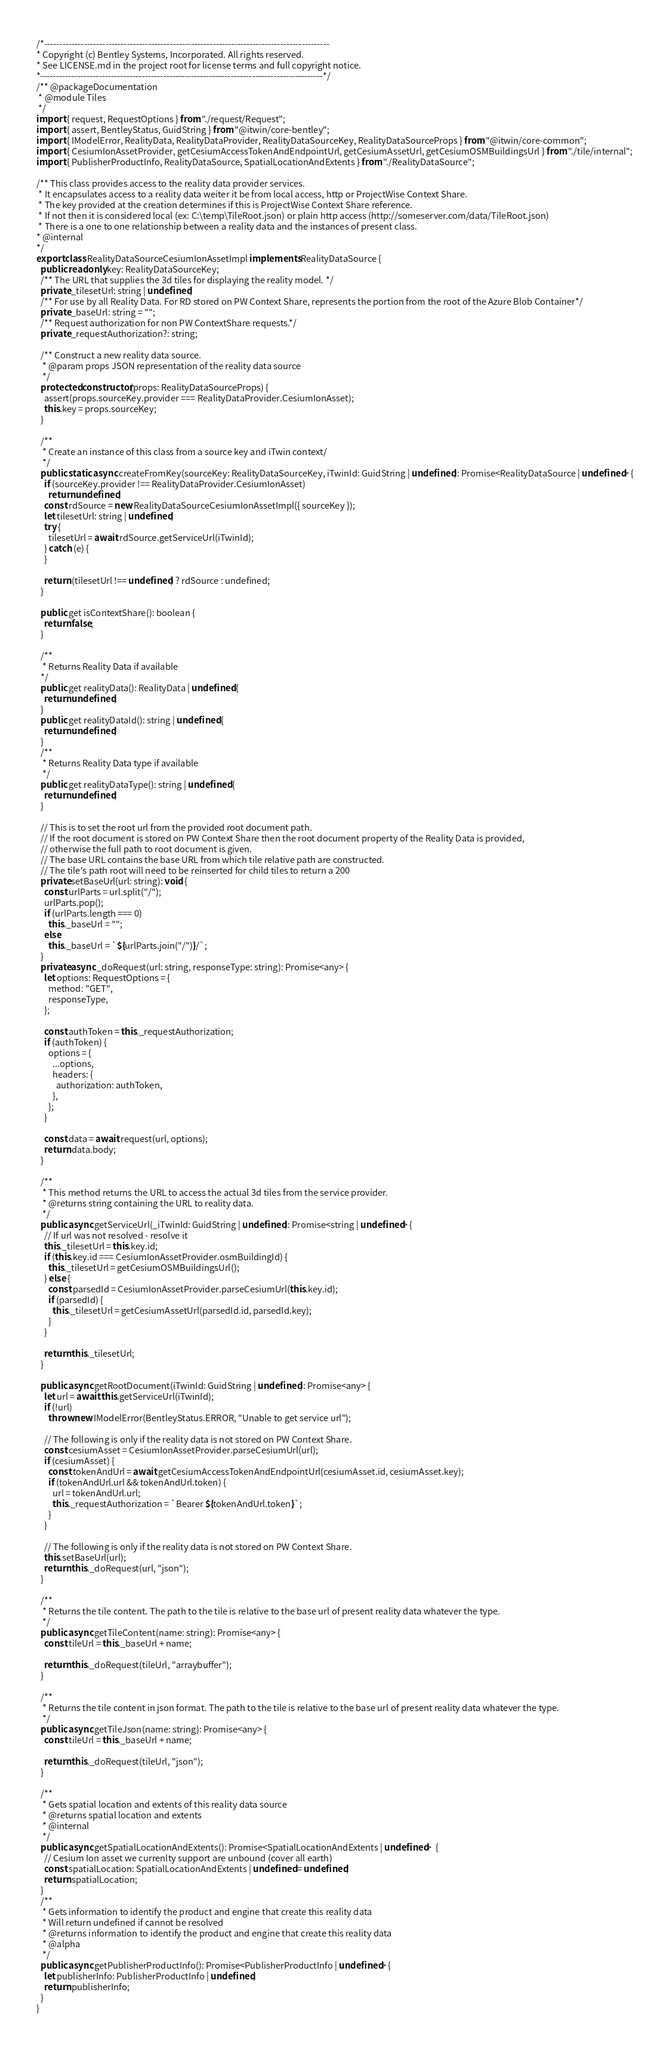<code> <loc_0><loc_0><loc_500><loc_500><_TypeScript_>/*---------------------------------------------------------------------------------------------
* Copyright (c) Bentley Systems, Incorporated. All rights reserved.
* See LICENSE.md in the project root for license terms and full copyright notice.
*--------------------------------------------------------------------------------------------*/
/** @packageDocumentation
 * @module Tiles
 */
import { request, RequestOptions } from "./request/Request";
import { assert, BentleyStatus, GuidString } from "@itwin/core-bentley";
import { IModelError, RealityData, RealityDataProvider, RealityDataSourceKey, RealityDataSourceProps } from "@itwin/core-common";
import { CesiumIonAssetProvider, getCesiumAccessTokenAndEndpointUrl, getCesiumAssetUrl, getCesiumOSMBuildingsUrl } from "./tile/internal";
import { PublisherProductInfo, RealityDataSource, SpatialLocationAndExtents } from "./RealityDataSource";

/** This class provides access to the reality data provider services.
 * It encapsulates access to a reality data weiter it be from local access, http or ProjectWise Context Share.
 * The key provided at the creation determines if this is ProjectWise Context Share reference.
 * If not then it is considered local (ex: C:\temp\TileRoot.json) or plain http access (http://someserver.com/data/TileRoot.json)
 * There is a one to one relationship between a reality data and the instances of present class.
* @internal
*/
export class RealityDataSourceCesiumIonAssetImpl implements RealityDataSource {
  public readonly key: RealityDataSourceKey;
  /** The URL that supplies the 3d tiles for displaying the reality model. */
  private _tilesetUrl: string | undefined;
  /** For use by all Reality Data. For RD stored on PW Context Share, represents the portion from the root of the Azure Blob Container*/
  private _baseUrl: string = "";
  /** Request authorization for non PW ContextShare requests.*/
  private _requestAuthorization?: string;

  /** Construct a new reality data source.
   * @param props JSON representation of the reality data source
   */
  protected constructor(props: RealityDataSourceProps) {
    assert(props.sourceKey.provider === RealityDataProvider.CesiumIonAsset);
    this.key = props.sourceKey;
  }

  /**
   * Create an instance of this class from a source key and iTwin context/
   */
  public static async createFromKey(sourceKey: RealityDataSourceKey, iTwinId: GuidString | undefined): Promise<RealityDataSource | undefined> {
    if (sourceKey.provider !== RealityDataProvider.CesiumIonAsset)
      return undefined;
    const rdSource = new RealityDataSourceCesiumIonAssetImpl({ sourceKey });
    let tilesetUrl: string | undefined;
    try {
      tilesetUrl = await rdSource.getServiceUrl(iTwinId);
    } catch (e) {
    }

    return (tilesetUrl !== undefined) ? rdSource : undefined;
  }

  public get isContextShare(): boolean {
    return false;
  }

  /**
   * Returns Reality Data if available
  */
  public get realityData(): RealityData | undefined {
    return undefined;
  }
  public get realityDataId(): string | undefined {
    return undefined;
  }
  /**
   * Returns Reality Data type if available
   */
  public get realityDataType(): string | undefined {
    return undefined;
  }

  // This is to set the root url from the provided root document path.
  // If the root document is stored on PW Context Share then the root document property of the Reality Data is provided,
  // otherwise the full path to root document is given.
  // The base URL contains the base URL from which tile relative path are constructed.
  // The tile's path root will need to be reinserted for child tiles to return a 200
  private setBaseUrl(url: string): void {
    const urlParts = url.split("/");
    urlParts.pop();
    if (urlParts.length === 0)
      this._baseUrl = "";
    else
      this._baseUrl = `${urlParts.join("/")}/`;
  }
  private async _doRequest(url: string, responseType: string): Promise<any> {
    let options: RequestOptions = {
      method: "GET",
      responseType,
    };

    const authToken = this._requestAuthorization;
    if (authToken) {
      options = {
        ...options,
        headers: {
          authorization: authToken,
        },
      };
    }

    const data = await request(url, options);
    return data.body;
  }

  /**
   * This method returns the URL to access the actual 3d tiles from the service provider.
   * @returns string containing the URL to reality data.
   */
  public async getServiceUrl(_iTwinId: GuidString | undefined): Promise<string | undefined> {
    // If url was not resolved - resolve it
    this._tilesetUrl = this.key.id;
    if (this.key.id === CesiumIonAssetProvider.osmBuildingId) {
      this._tilesetUrl = getCesiumOSMBuildingsUrl();
    } else {
      const parsedId = CesiumIonAssetProvider.parseCesiumUrl(this.key.id);
      if (parsedId) {
        this._tilesetUrl = getCesiumAssetUrl(parsedId.id, parsedId.key);
      }
    }

    return this._tilesetUrl;
  }

  public async getRootDocument(iTwinId: GuidString | undefined): Promise<any> {
    let url = await this.getServiceUrl(iTwinId);
    if (!url)
      throw new IModelError(BentleyStatus.ERROR, "Unable to get service url");

    // The following is only if the reality data is not stored on PW Context Share.
    const cesiumAsset = CesiumIonAssetProvider.parseCesiumUrl(url);
    if (cesiumAsset) {
      const tokenAndUrl = await getCesiumAccessTokenAndEndpointUrl(cesiumAsset.id, cesiumAsset.key);
      if (tokenAndUrl.url && tokenAndUrl.token) {
        url = tokenAndUrl.url;
        this._requestAuthorization = `Bearer ${tokenAndUrl.token}`;
      }
    }

    // The following is only if the reality data is not stored on PW Context Share.
    this.setBaseUrl(url);
    return this._doRequest(url, "json");
  }

  /**
   * Returns the tile content. The path to the tile is relative to the base url of present reality data whatever the type.
   */
  public async getTileContent(name: string): Promise<any> {
    const tileUrl = this._baseUrl + name;

    return this._doRequest(tileUrl, "arraybuffer");
  }

  /**
   * Returns the tile content in json format. The path to the tile is relative to the base url of present reality data whatever the type.
   */
  public async getTileJson(name: string): Promise<any> {
    const tileUrl = this._baseUrl + name;

    return this._doRequest(tileUrl, "json");
  }

  /**
   * Gets spatial location and extents of this reality data source
   * @returns spatial location and extents
   * @internal
   */
  public async getSpatialLocationAndExtents(): Promise<SpatialLocationAndExtents | undefined>  {
    // Cesium Ion asset we currenlty support are unbound (cover all earth)
    const spatialLocation: SpatialLocationAndExtents | undefined = undefined;
    return spatialLocation;
  }
  /**
   * Gets information to identify the product and engine that create this reality data
   * Will return undefined if cannot be resolved
   * @returns information to identify the product and engine that create this reality data
   * @alpha
   */
  public async getPublisherProductInfo(): Promise<PublisherProductInfo | undefined> {
    let publisherInfo: PublisherProductInfo | undefined;
    return publisherInfo;
  }
}

</code> 